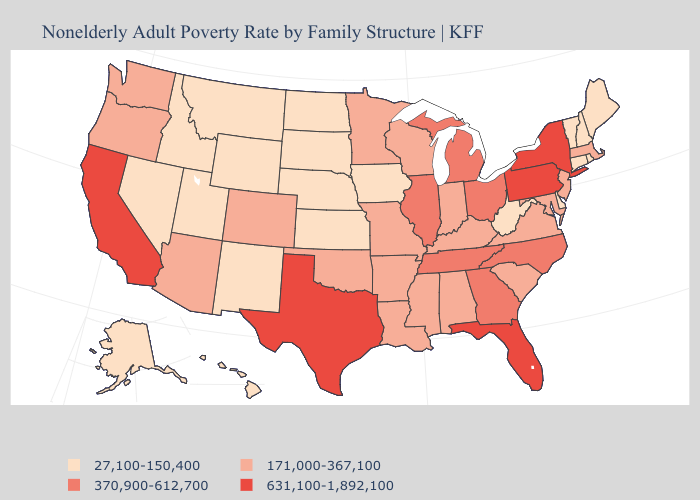Does North Carolina have a higher value than New York?
Be succinct. No. Name the states that have a value in the range 631,100-1,892,100?
Give a very brief answer. California, Florida, New York, Pennsylvania, Texas. Which states have the lowest value in the USA?
Be succinct. Alaska, Connecticut, Delaware, Hawaii, Idaho, Iowa, Kansas, Maine, Montana, Nebraska, Nevada, New Hampshire, New Mexico, North Dakota, Rhode Island, South Dakota, Utah, Vermont, West Virginia, Wyoming. Does Michigan have the lowest value in the USA?
Keep it brief. No. Does Indiana have the lowest value in the MidWest?
Quick response, please. No. What is the value of Connecticut?
Give a very brief answer. 27,100-150,400. What is the value of Utah?
Short answer required. 27,100-150,400. Name the states that have a value in the range 631,100-1,892,100?
Concise answer only. California, Florida, New York, Pennsylvania, Texas. Does Massachusetts have the lowest value in the USA?
Keep it brief. No. Name the states that have a value in the range 27,100-150,400?
Answer briefly. Alaska, Connecticut, Delaware, Hawaii, Idaho, Iowa, Kansas, Maine, Montana, Nebraska, Nevada, New Hampshire, New Mexico, North Dakota, Rhode Island, South Dakota, Utah, Vermont, West Virginia, Wyoming. Does Virginia have the lowest value in the USA?
Short answer required. No. Is the legend a continuous bar?
Keep it brief. No. Which states have the lowest value in the USA?
Concise answer only. Alaska, Connecticut, Delaware, Hawaii, Idaho, Iowa, Kansas, Maine, Montana, Nebraska, Nevada, New Hampshire, New Mexico, North Dakota, Rhode Island, South Dakota, Utah, Vermont, West Virginia, Wyoming. What is the value of New York?
Answer briefly. 631,100-1,892,100. Does Hawaii have the same value as Nevada?
Be succinct. Yes. 